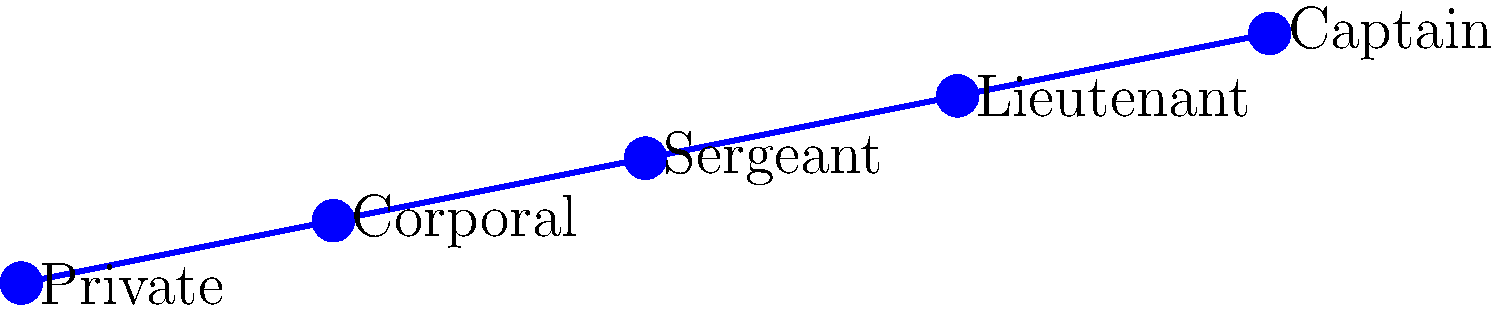As a magazine editor, you're reviewing a step chart that tracks a veteran's career progression. The chart shows rank changes every five years from 2000 to 2020. What is the total number of rank advancements the veteran experienced during this period? To determine the number of rank advancements, we need to analyze the step chart:

1. In 2000, the veteran's rank was Private.
2. In 2005, the rank increased to Corporal (1st advancement).
3. In 2010, the rank increased to Sergeant (2nd advancement).
4. In 2015, the rank increased to Lieutenant (3rd advancement).
5. In 2020, the rank increased to Captain (4th advancement).

Each step up in the chart represents a rank advancement. We can count 4 distinct steps from Private to Captain.
Answer: 4 advancements 